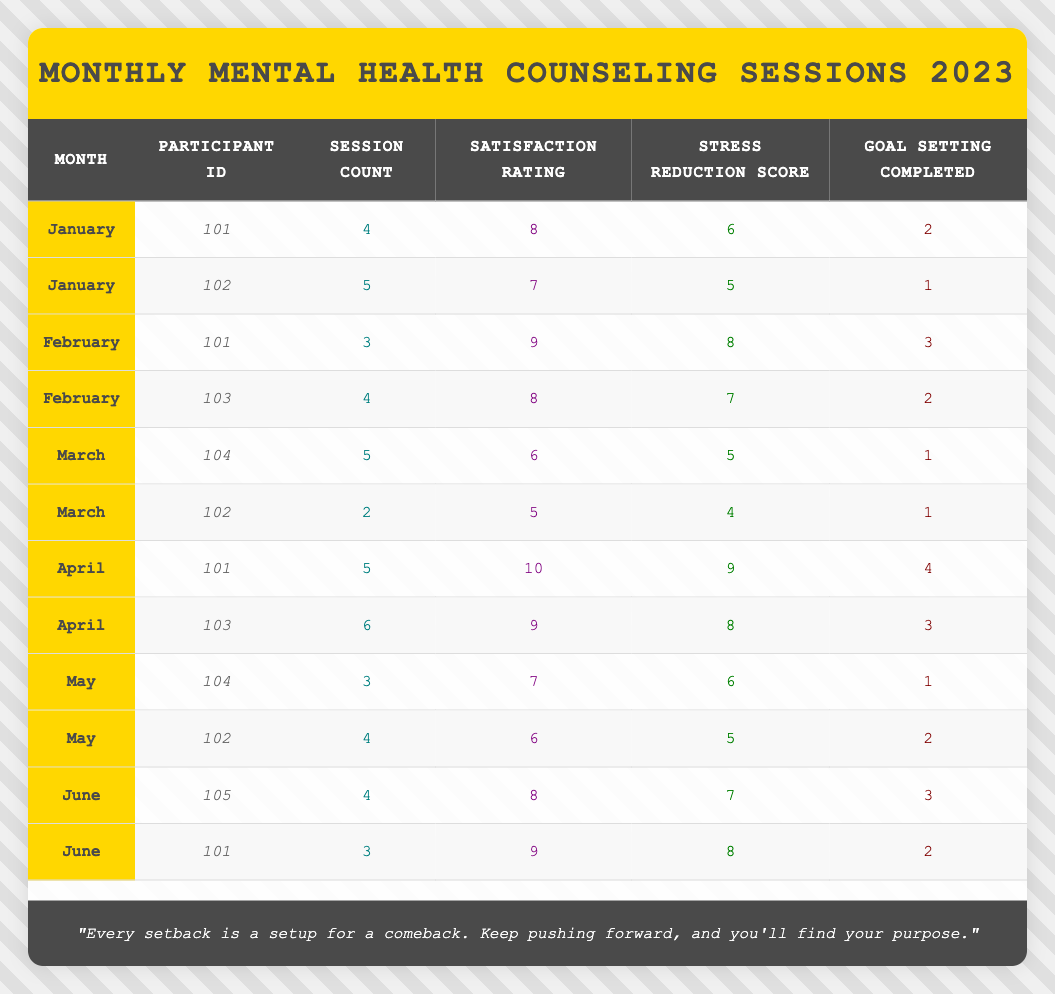What is the satisfaction rating for participant ID 101 in April? In April, participant ID 101 has a satisfaction rating listed in the table as 10.
Answer: 10 How many sessions did participant ID 102 attend in January? The table shows that participant ID 102 attended 5 sessions in January.
Answer: 5 Which participant completed the most goal settings in March? In March, participant ID 102 and participant ID 104 both had 1 goal setting completed, but the question asks for the most. Therefore, neither completed more than one.
Answer: None What is the average satisfaction rating across all participants in February? The satisfaction ratings in February are 9 (for ID 101) and 8 (for ID 103). Adding them gives 17, and dividing by 2 (number of participants) results in an average of 8.5.
Answer: 8.5 Did participant ID 103 complete any goals in its first session? Looking at the rows for participant ID 103, in January, it has no entry. It first appears in February with 2 goals completed, showing that it had no goals in January.
Answer: No What is the total number of sessions attended by participant ID 101 from January to June? The sessions attended by participant ID 101 are 4 (January), 3 (February), 5 (April), and 3 (June). Adding these gives a total of 15 sessions (4 + 3 + 5 + 3 = 15).
Answer: 15 Which participant had the highest stress reduction score in June? The only participants in June are 101 (score of 8) and 105 (score of 7). The highest stress reduction score is 8 for participant ID 101.
Answer: 8 For which month did participant ID 104 have a session count of 3? Looking through the table, participant ID 104 only has 3 sessions recorded in May.
Answer: May What is the difference in goal settings completed between participant ID 101 in April and participant ID 102 in March? Participant ID 101 in April completed 4 goal settings, while participant ID 102 in March completed 1. Thus, the difference is 4 - 1 = 3.
Answer: 3 During which month did participant ID 105 first attend the sessions? The table shows that participant ID 105 shows up in June, indicating this was their first attended month.
Answer: June 